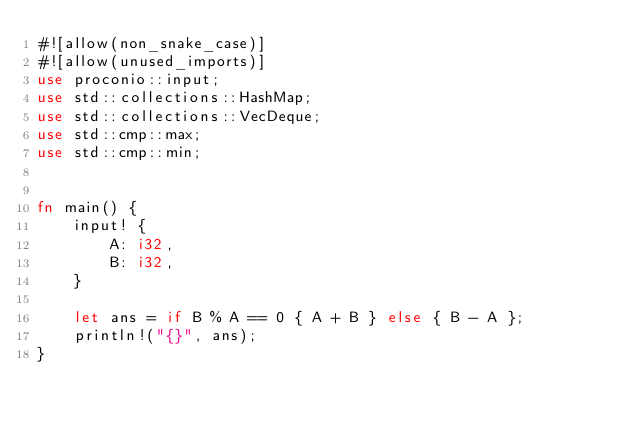Convert code to text. <code><loc_0><loc_0><loc_500><loc_500><_Rust_>#![allow(non_snake_case)]
#![allow(unused_imports)]
use proconio::input;
use std::collections::HashMap;
use std::collections::VecDeque;
use std::cmp::max;
use std::cmp::min;


fn main() {
    input! {
        A: i32,
        B: i32,
    }

    let ans = if B % A == 0 { A + B } else { B - A };
    println!("{}", ans);
}
</code> 